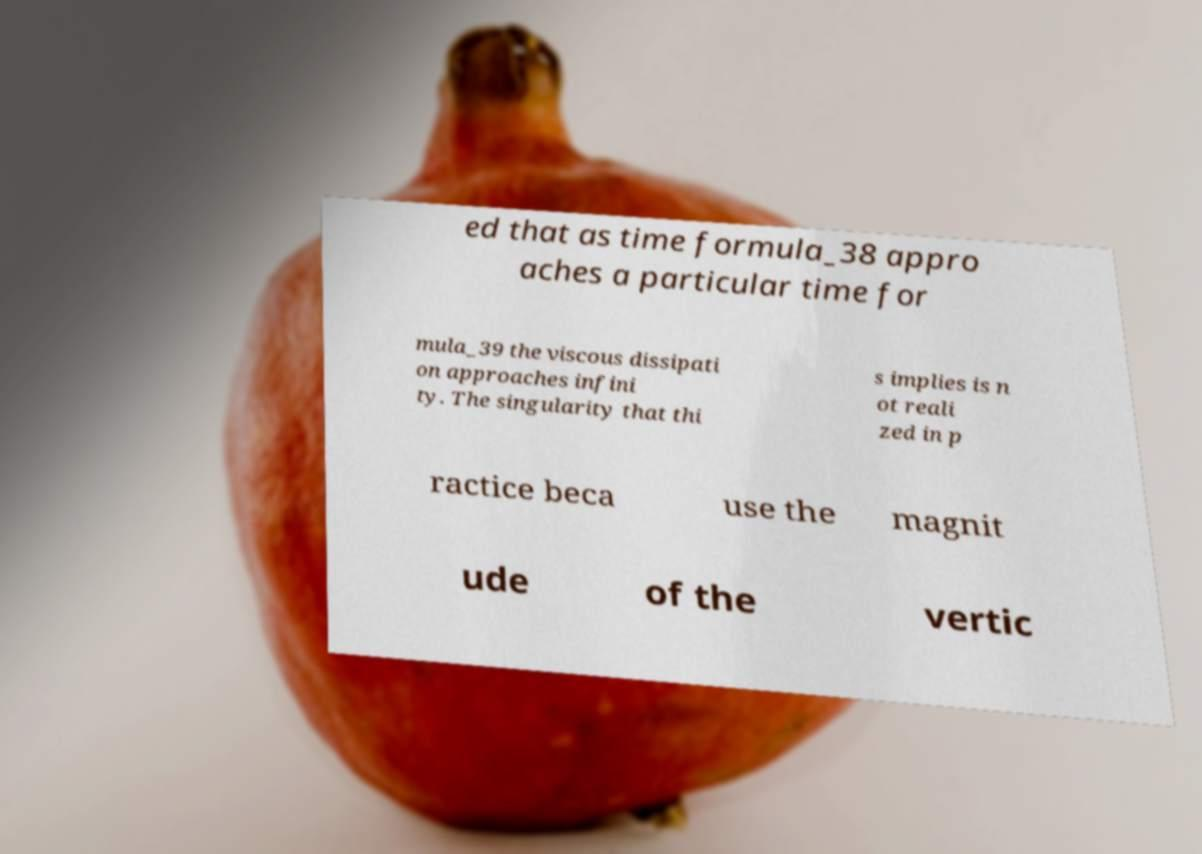Could you assist in decoding the text presented in this image and type it out clearly? ed that as time formula_38 appro aches a particular time for mula_39 the viscous dissipati on approaches infini ty. The singularity that thi s implies is n ot reali zed in p ractice beca use the magnit ude of the vertic 